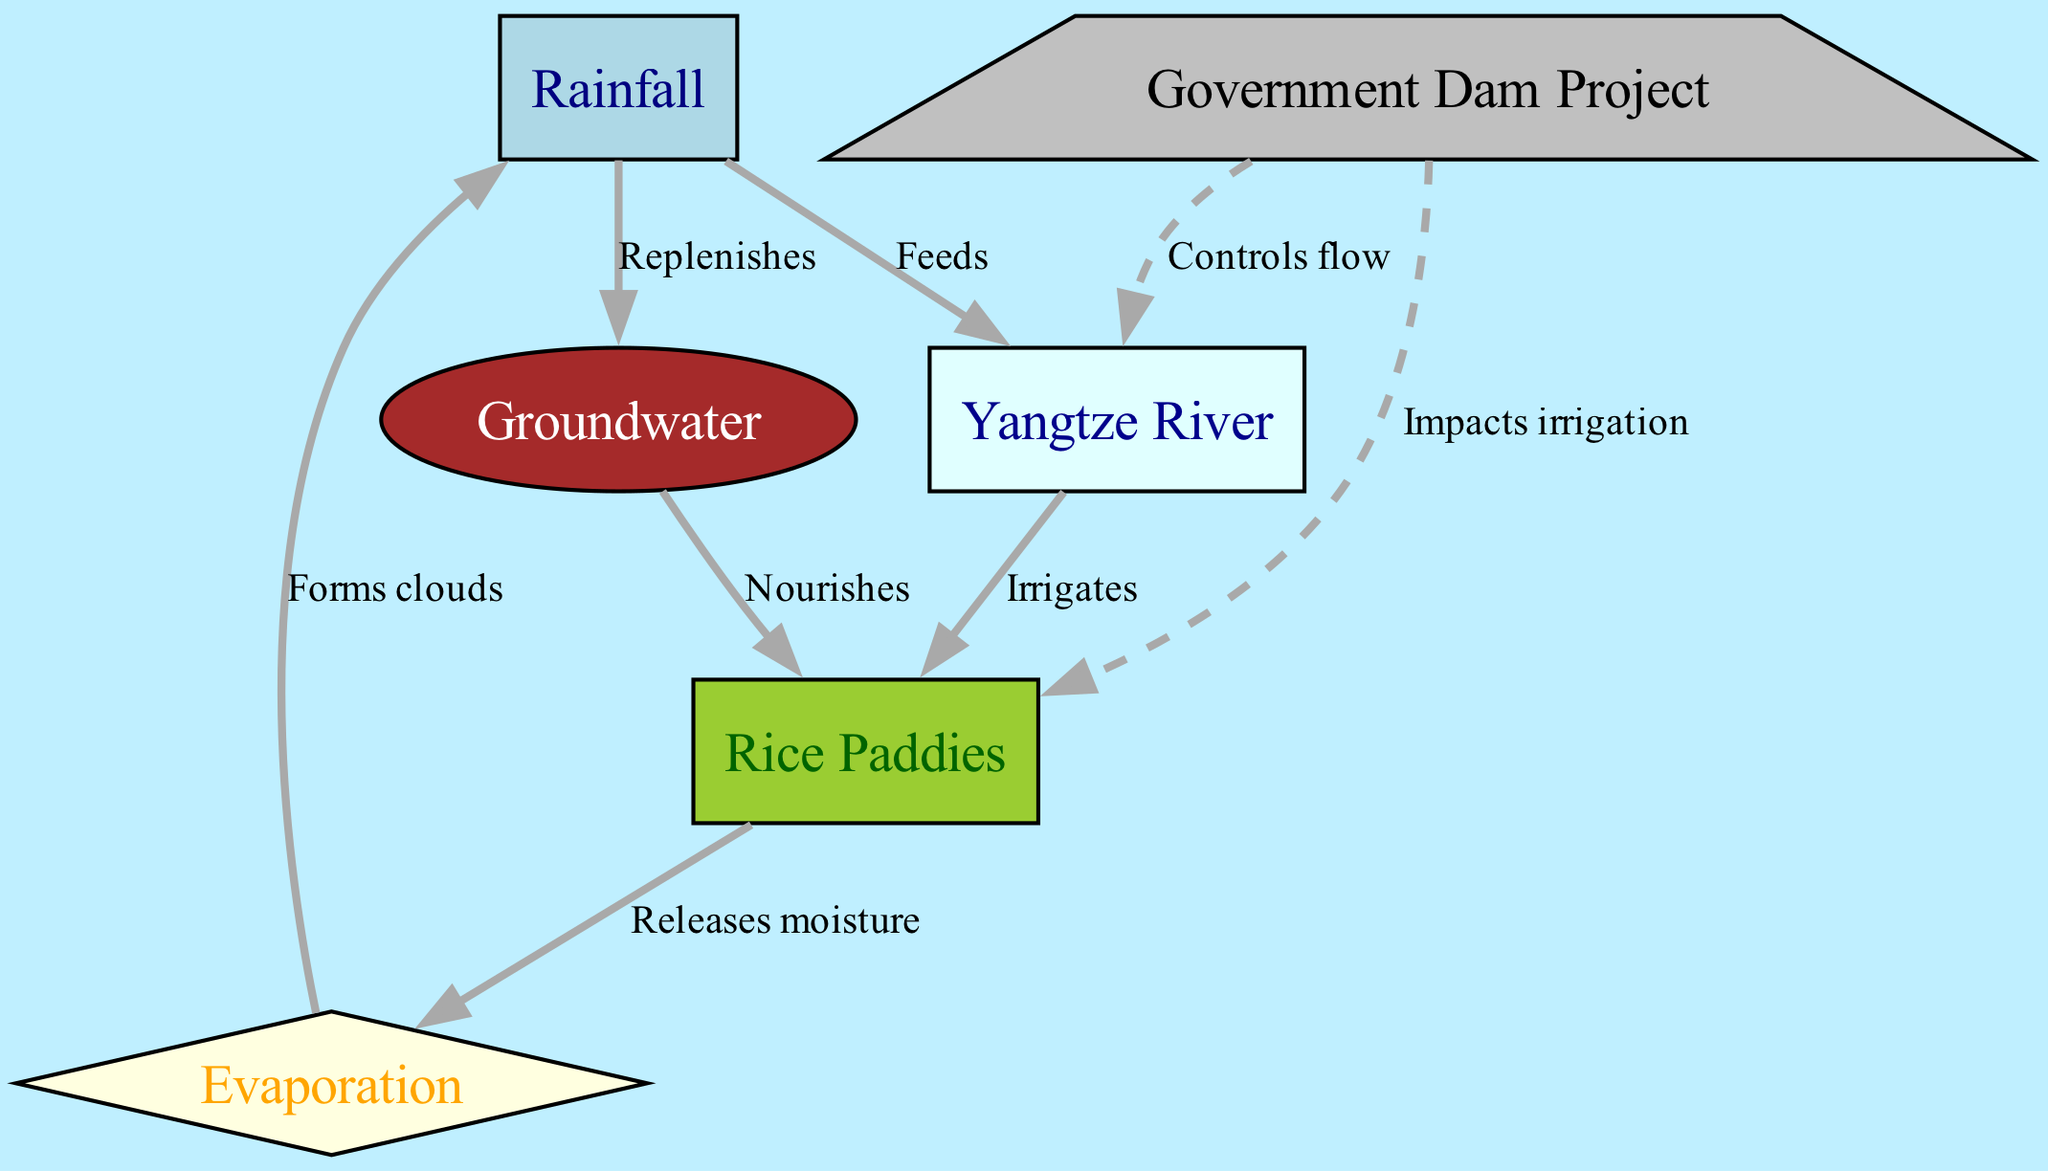What is the main source of irrigation for the rice paddies? The diagram indicates that the Yangtze River irrigates the rice paddies, as represented by the edge connecting the river to the crops labeled "Irrigates."
Answer: Yangtze River How many nodes are there in the diagram? Counting the nodes listed in the diagram shows there are six in total: Rainfall, Yangtze River, Groundwater, Rice Paddies, Evaporation, and Government Dam Project.
Answer: 6 What role does groundwater play in agricultural practices? The diagram shows that groundwater nourishes the crops, as noted by the edge connecting groundwater to crops labeled "Nourishes."
Answer: Nourishes What contributes to the formation of clouds in the water cycle? According to the diagram, evaporation releases moisture which then forms clouds, indicated by the edge connecting evaporation to rainfall labeled "Forms clouds."
Answer: Evaporation Which government project impacts irrigation in the village? The diagram specifies the Government Dam Project as impacting irrigation, shown by the edge linking the dam to crops labeled "Impacts irrigation."
Answer: Government Dam Project What two processes feed into the Yangtze River? The diagram illustrates that rainfall feeds into the Yangtze River and shows this with the edge labeled "Feeds" connecting rainfall to the river. Additionally, there is a concept of control from the dam, but it is not feeding directly; hence, the primary answer is just rainfall.
Answer: Rainfall How does evaporation relate to the rice paddies? The diagram indicates that crops release moisture through evaporation, as noted by the edge connecting crops to evaporation labeled "Releases moisture."
Answer: Releases moisture What mechanism controls the water flow in the Yangtze River? It is clear from the diagram that the Government Dam Project controls the flow of the river, as indicated by the edge connecting the dam to the river labeled "Controls flow."
Answer: Government Dam Project 